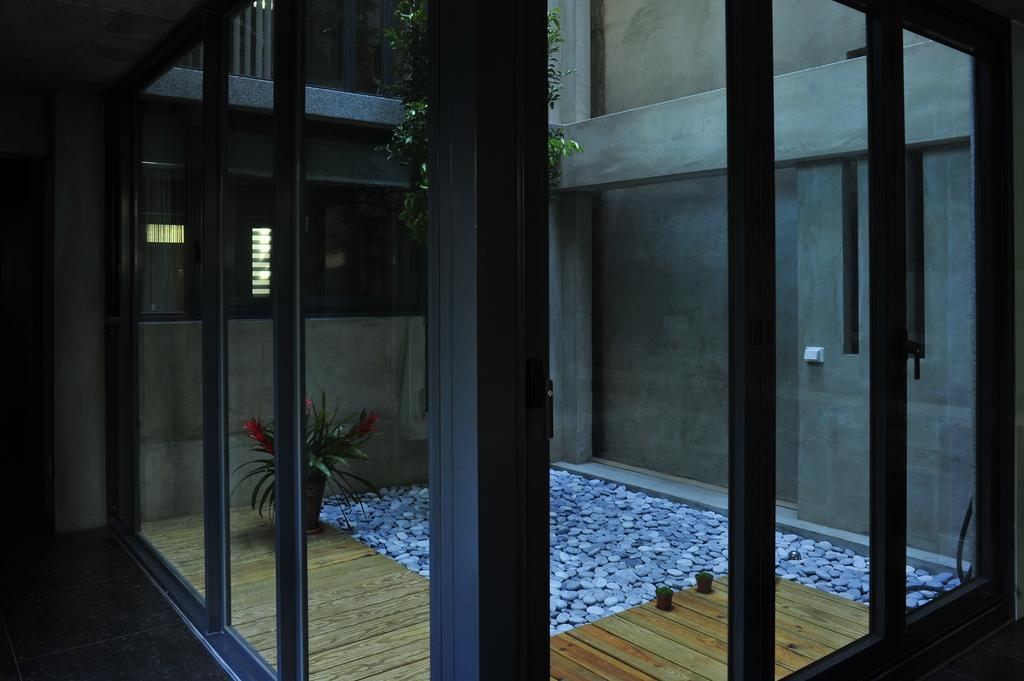What type of wall is present in the image? The image contains a glass wall. What can be seen inside the glass wall? There are stones in the glass wall. Where is the plant pot located in relation to the glass wall? The plant pot is on the left side of the glass wall. What type of discovery was made in the image? There is no mention of a discovery in the image; it features a glass wall with stones and a plant pot. 